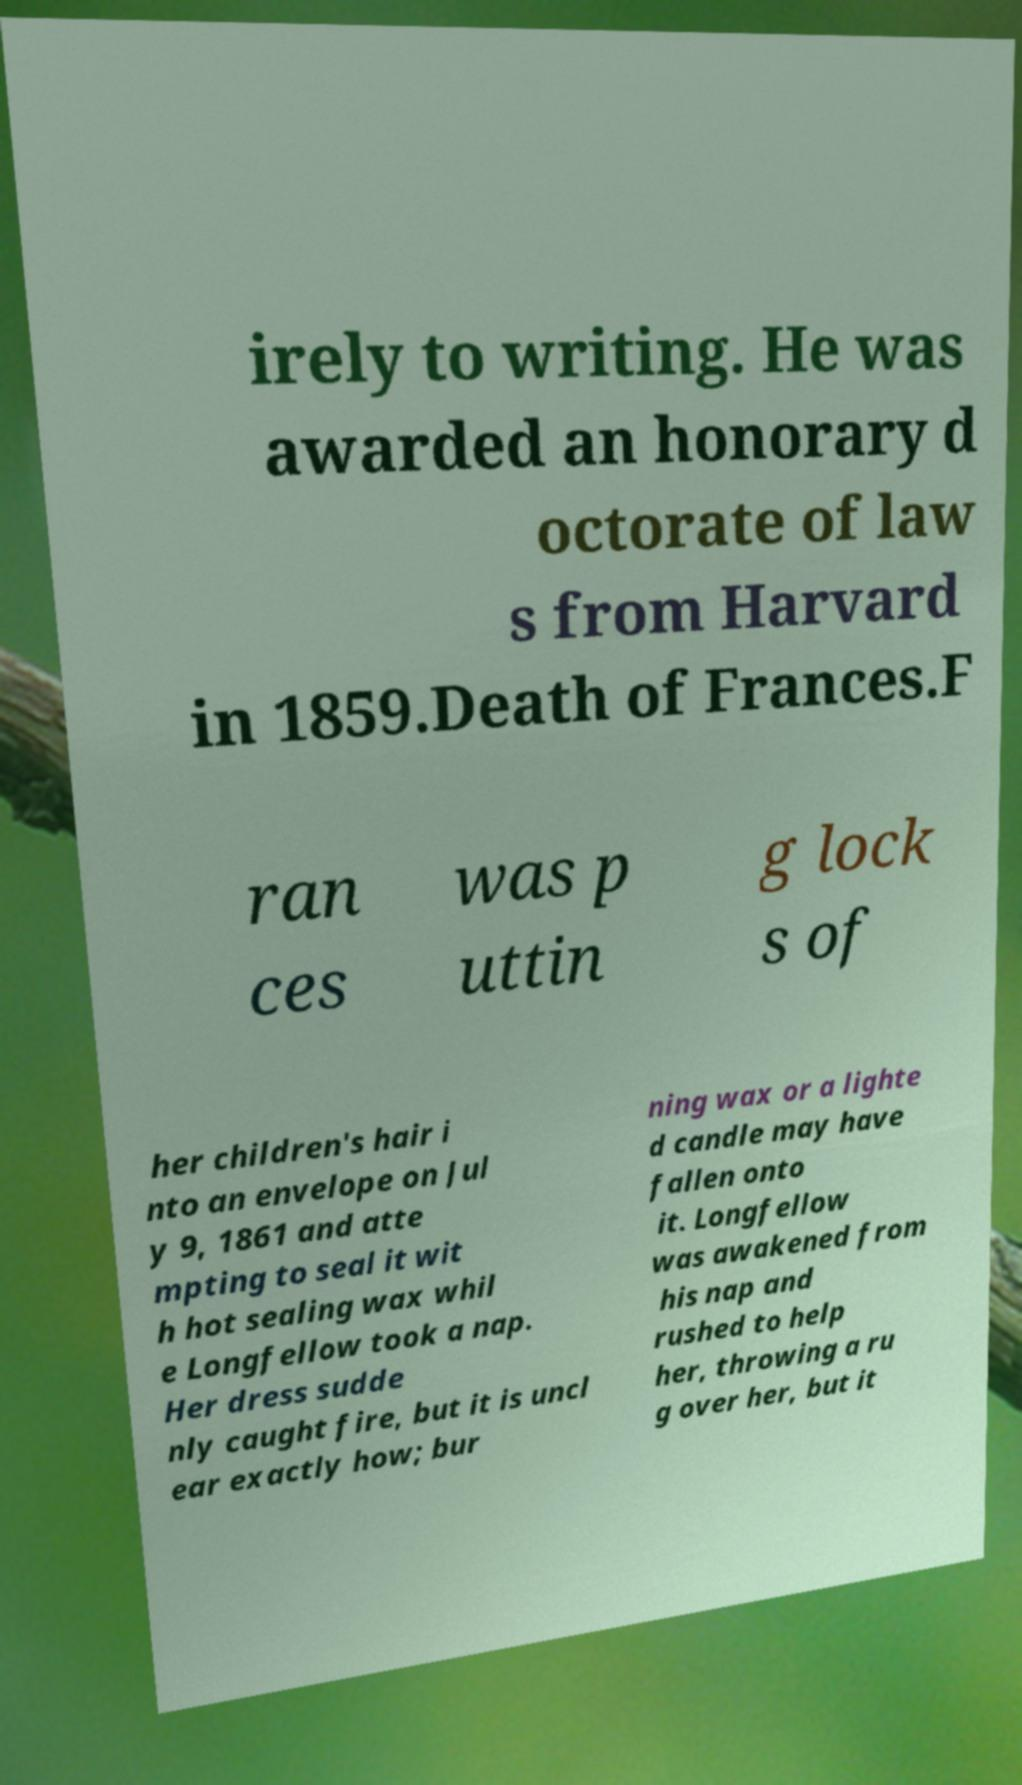Could you assist in decoding the text presented in this image and type it out clearly? irely to writing. He was awarded an honorary d octorate of law s from Harvard in 1859.Death of Frances.F ran ces was p uttin g lock s of her children's hair i nto an envelope on Jul y 9, 1861 and atte mpting to seal it wit h hot sealing wax whil e Longfellow took a nap. Her dress sudde nly caught fire, but it is uncl ear exactly how; bur ning wax or a lighte d candle may have fallen onto it. Longfellow was awakened from his nap and rushed to help her, throwing a ru g over her, but it 